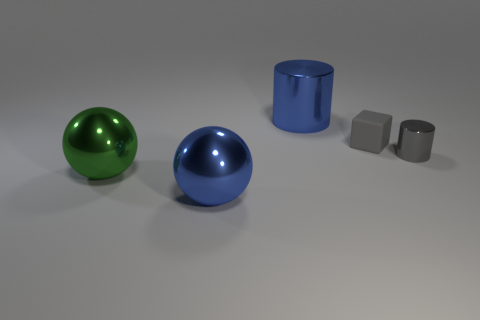Add 3 large purple objects. How many objects exist? 8 Subtract all cylinders. How many objects are left? 3 Subtract all small rubber blocks. Subtract all blue cylinders. How many objects are left? 3 Add 4 gray things. How many gray things are left? 6 Add 2 big brown metallic spheres. How many big brown metallic spheres exist? 2 Subtract 0 purple balls. How many objects are left? 5 